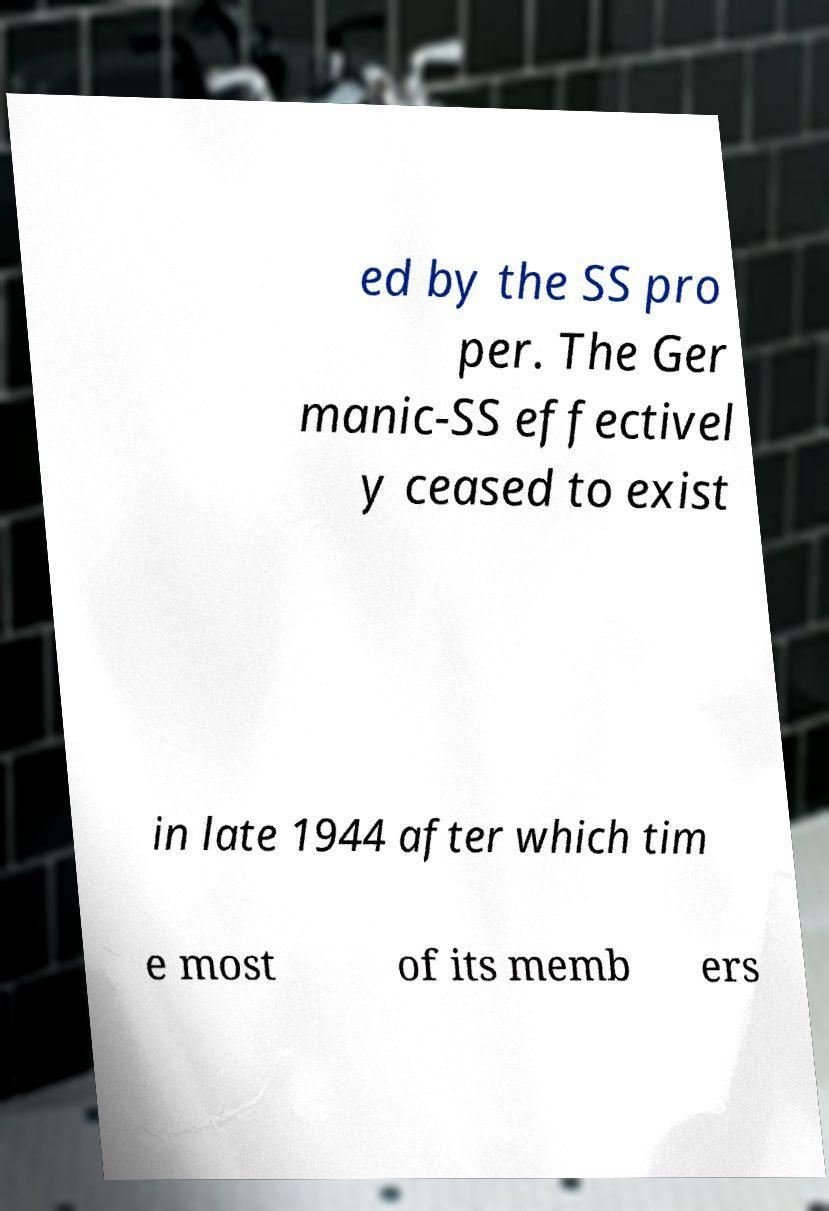Can you read and provide the text displayed in the image?This photo seems to have some interesting text. Can you extract and type it out for me? ed by the SS pro per. The Ger manic-SS effectivel y ceased to exist in late 1944 after which tim e most of its memb ers 